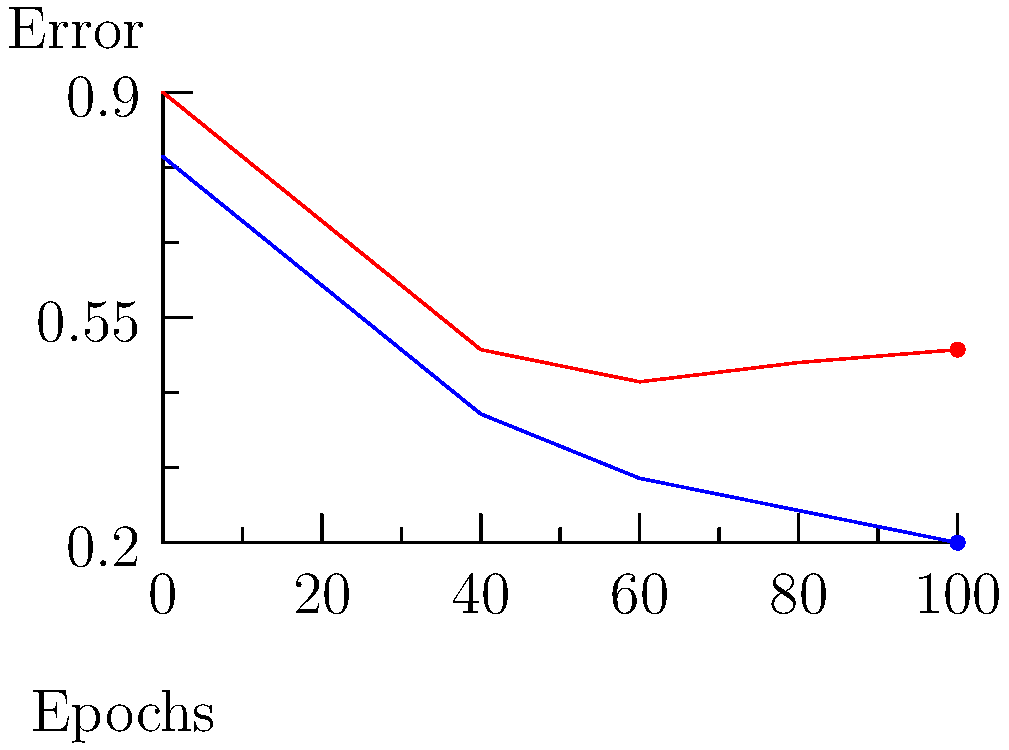Analyze the learning curve graph and determine at which epoch the model starts to overfit. How might this insight help improve your model's performance? Let's analyze this learning curve step-by-step:

1. The blue line represents the training error, which consistently decreases over epochs.
2. The red line represents the validation error, which initially decreases but then starts to increase.
3. Overfitting occurs when the model performs well on the training data but poorly on unseen (validation) data.
4. In this graph, the validation error starts to increase around the 60th epoch, while the training error continues to decrease.
5. This divergence between training and validation errors indicates the onset of overfitting.
6. To improve the model's performance, we could:
   a) Stop training at around the 60th epoch (early stopping).
   b) Implement regularization techniques to prevent overfitting.
   c) Increase the amount or diversity of training data.
   d) Simplify the model architecture to reduce its capacity to memorize training data.

By identifying the point of overfitting, we can optimize our model to generalize better on unseen data, thus improving its real-world performance.
Answer: The model starts to overfit around the 60th epoch. This insight can be used to implement early stopping or other regularization techniques to improve generalization. 